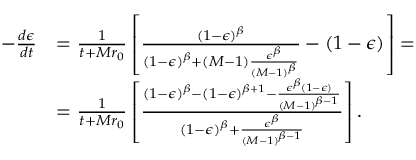<formula> <loc_0><loc_0><loc_500><loc_500>\begin{array} { r l } { - \frac { d \epsilon } { d t } } & { = \frac { 1 } { t + M r _ { 0 } } \left [ \frac { ( 1 - \epsilon ) ^ { \beta } } { ( 1 - \epsilon ) ^ { \beta } + ( M - 1 ) \frac { \epsilon ^ { \beta } } { ( M - 1 ) ^ { \beta } } } - ( 1 - \epsilon ) \right ] = } \\ & { = \frac { 1 } { t + M r _ { 0 } } \left [ \frac { ( 1 - \epsilon ) ^ { \beta } - ( 1 - \epsilon ) ^ { \beta + 1 } - \frac { \epsilon ^ { \beta } ( 1 - \epsilon ) } { ( M - 1 ) ^ { \beta - 1 } } } { ( 1 - \epsilon ) ^ { \beta } + \frac { \epsilon ^ { \beta } } { ( M - 1 ) ^ { \beta - 1 } } } \right ] . } \end{array}</formula> 